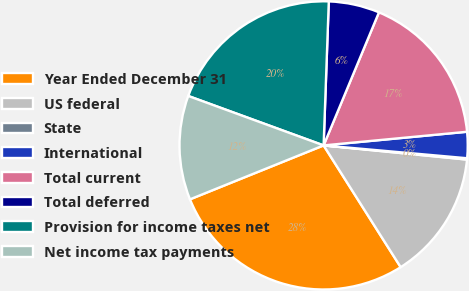<chart> <loc_0><loc_0><loc_500><loc_500><pie_chart><fcel>Year Ended December 31<fcel>US federal<fcel>State<fcel>International<fcel>Total current<fcel>Total deferred<fcel>Provision for income taxes net<fcel>Net income tax payments<nl><fcel>27.88%<fcel>14.45%<fcel>0.15%<fcel>2.93%<fcel>17.22%<fcel>5.7%<fcel>20.0%<fcel>11.68%<nl></chart> 